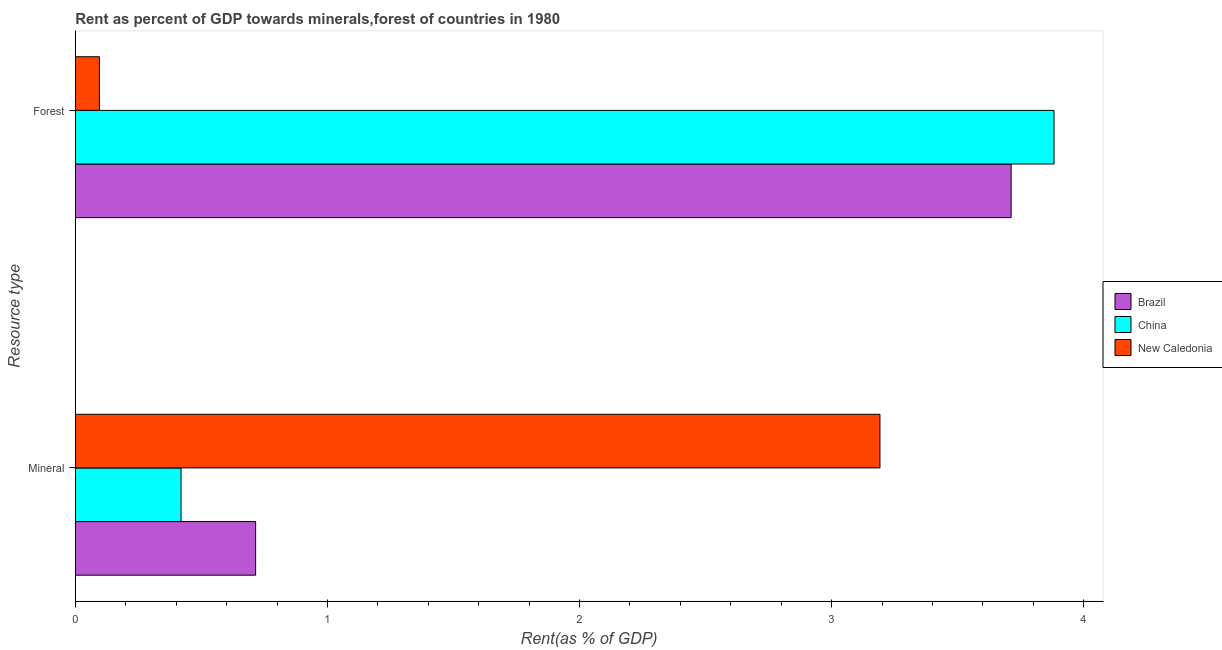How many different coloured bars are there?
Give a very brief answer. 3. How many groups of bars are there?
Provide a succinct answer. 2. Are the number of bars per tick equal to the number of legend labels?
Keep it short and to the point. Yes. How many bars are there on the 2nd tick from the top?
Your response must be concise. 3. How many bars are there on the 1st tick from the bottom?
Offer a very short reply. 3. What is the label of the 1st group of bars from the top?
Keep it short and to the point. Forest. What is the forest rent in China?
Your answer should be compact. 3.88. Across all countries, what is the maximum mineral rent?
Your answer should be compact. 3.19. Across all countries, what is the minimum mineral rent?
Offer a very short reply. 0.42. In which country was the mineral rent maximum?
Your answer should be compact. New Caledonia. In which country was the forest rent minimum?
Your answer should be compact. New Caledonia. What is the total mineral rent in the graph?
Keep it short and to the point. 4.33. What is the difference between the mineral rent in China and that in Brazil?
Your answer should be very brief. -0.3. What is the difference between the forest rent in New Caledonia and the mineral rent in China?
Give a very brief answer. -0.32. What is the average forest rent per country?
Keep it short and to the point. 2.56. What is the difference between the mineral rent and forest rent in New Caledonia?
Offer a terse response. 3.1. In how many countries, is the forest rent greater than 2 %?
Keep it short and to the point. 2. What is the ratio of the mineral rent in New Caledonia to that in Brazil?
Your answer should be very brief. 4.46. Is the mineral rent in New Caledonia less than that in Brazil?
Make the answer very short. No. What does the 3rd bar from the bottom in Forest represents?
Ensure brevity in your answer.  New Caledonia. How many countries are there in the graph?
Your answer should be very brief. 3. Does the graph contain any zero values?
Provide a short and direct response. No. Does the graph contain grids?
Make the answer very short. No. How many legend labels are there?
Your answer should be very brief. 3. What is the title of the graph?
Provide a short and direct response. Rent as percent of GDP towards minerals,forest of countries in 1980. What is the label or title of the X-axis?
Your answer should be compact. Rent(as % of GDP). What is the label or title of the Y-axis?
Provide a succinct answer. Resource type. What is the Rent(as % of GDP) of Brazil in Mineral?
Give a very brief answer. 0.72. What is the Rent(as % of GDP) in China in Mineral?
Ensure brevity in your answer.  0.42. What is the Rent(as % of GDP) in New Caledonia in Mineral?
Make the answer very short. 3.19. What is the Rent(as % of GDP) of Brazil in Forest?
Your answer should be very brief. 3.71. What is the Rent(as % of GDP) of China in Forest?
Keep it short and to the point. 3.88. What is the Rent(as % of GDP) of New Caledonia in Forest?
Give a very brief answer. 0.1. Across all Resource type, what is the maximum Rent(as % of GDP) of Brazil?
Your answer should be very brief. 3.71. Across all Resource type, what is the maximum Rent(as % of GDP) of China?
Offer a very short reply. 3.88. Across all Resource type, what is the maximum Rent(as % of GDP) of New Caledonia?
Your answer should be compact. 3.19. Across all Resource type, what is the minimum Rent(as % of GDP) in Brazil?
Provide a succinct answer. 0.72. Across all Resource type, what is the minimum Rent(as % of GDP) in China?
Offer a terse response. 0.42. Across all Resource type, what is the minimum Rent(as % of GDP) of New Caledonia?
Your answer should be very brief. 0.1. What is the total Rent(as % of GDP) of Brazil in the graph?
Offer a very short reply. 4.43. What is the total Rent(as % of GDP) in China in the graph?
Keep it short and to the point. 4.3. What is the total Rent(as % of GDP) in New Caledonia in the graph?
Offer a very short reply. 3.29. What is the difference between the Rent(as % of GDP) in Brazil in Mineral and that in Forest?
Offer a very short reply. -3. What is the difference between the Rent(as % of GDP) of China in Mineral and that in Forest?
Offer a very short reply. -3.46. What is the difference between the Rent(as % of GDP) of New Caledonia in Mineral and that in Forest?
Provide a short and direct response. 3.1. What is the difference between the Rent(as % of GDP) of Brazil in Mineral and the Rent(as % of GDP) of China in Forest?
Provide a short and direct response. -3.17. What is the difference between the Rent(as % of GDP) in Brazil in Mineral and the Rent(as % of GDP) in New Caledonia in Forest?
Give a very brief answer. 0.62. What is the difference between the Rent(as % of GDP) in China in Mineral and the Rent(as % of GDP) in New Caledonia in Forest?
Offer a very short reply. 0.32. What is the average Rent(as % of GDP) of Brazil per Resource type?
Your answer should be very brief. 2.21. What is the average Rent(as % of GDP) of China per Resource type?
Offer a terse response. 2.15. What is the average Rent(as % of GDP) in New Caledonia per Resource type?
Provide a short and direct response. 1.64. What is the difference between the Rent(as % of GDP) in Brazil and Rent(as % of GDP) in China in Mineral?
Provide a succinct answer. 0.3. What is the difference between the Rent(as % of GDP) in Brazil and Rent(as % of GDP) in New Caledonia in Mineral?
Keep it short and to the point. -2.48. What is the difference between the Rent(as % of GDP) of China and Rent(as % of GDP) of New Caledonia in Mineral?
Make the answer very short. -2.77. What is the difference between the Rent(as % of GDP) in Brazil and Rent(as % of GDP) in China in Forest?
Your answer should be very brief. -0.17. What is the difference between the Rent(as % of GDP) in Brazil and Rent(as % of GDP) in New Caledonia in Forest?
Offer a terse response. 3.62. What is the difference between the Rent(as % of GDP) in China and Rent(as % of GDP) in New Caledonia in Forest?
Your response must be concise. 3.79. What is the ratio of the Rent(as % of GDP) of Brazil in Mineral to that in Forest?
Offer a very short reply. 0.19. What is the ratio of the Rent(as % of GDP) of China in Mineral to that in Forest?
Provide a succinct answer. 0.11. What is the ratio of the Rent(as % of GDP) in New Caledonia in Mineral to that in Forest?
Provide a succinct answer. 33.36. What is the difference between the highest and the second highest Rent(as % of GDP) of Brazil?
Keep it short and to the point. 3. What is the difference between the highest and the second highest Rent(as % of GDP) in China?
Offer a very short reply. 3.46. What is the difference between the highest and the second highest Rent(as % of GDP) in New Caledonia?
Keep it short and to the point. 3.1. What is the difference between the highest and the lowest Rent(as % of GDP) of Brazil?
Your answer should be very brief. 3. What is the difference between the highest and the lowest Rent(as % of GDP) in China?
Offer a very short reply. 3.46. What is the difference between the highest and the lowest Rent(as % of GDP) in New Caledonia?
Give a very brief answer. 3.1. 